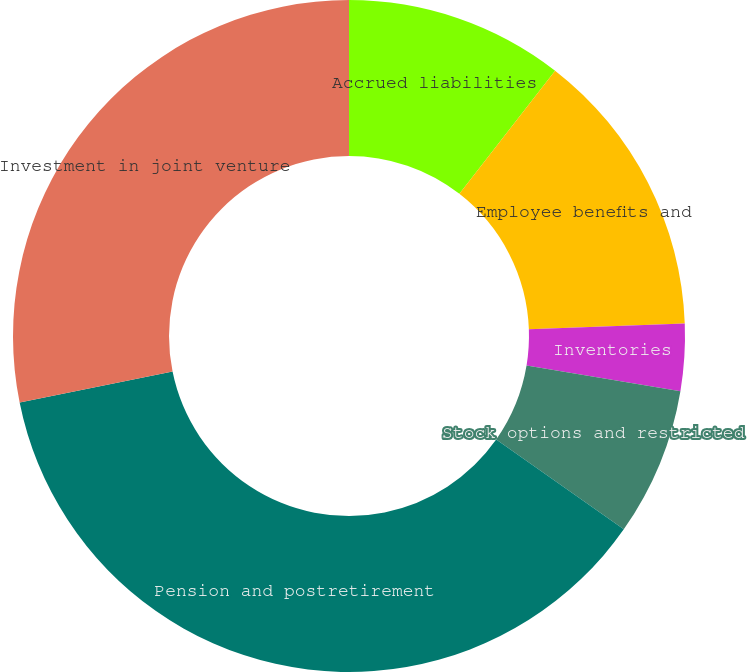Convert chart. <chart><loc_0><loc_0><loc_500><loc_500><pie_chart><fcel>Accrued liabilities<fcel>Employee benefits and<fcel>Inventories<fcel>Stock options and restricted<fcel>Pension and postretirement<fcel>Investment in joint venture<nl><fcel>10.51%<fcel>13.9%<fcel>3.22%<fcel>7.13%<fcel>37.07%<fcel>28.17%<nl></chart> 